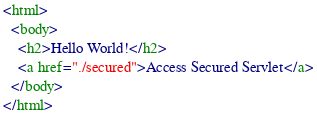Convert code to text. <code><loc_0><loc_0><loc_500><loc_500><_HTML_><html>
  <body>
    <h2>Hello World!</h2>
    <a href="./secured">Access Secured Servlet</a>
  </body>
</html>
</code> 